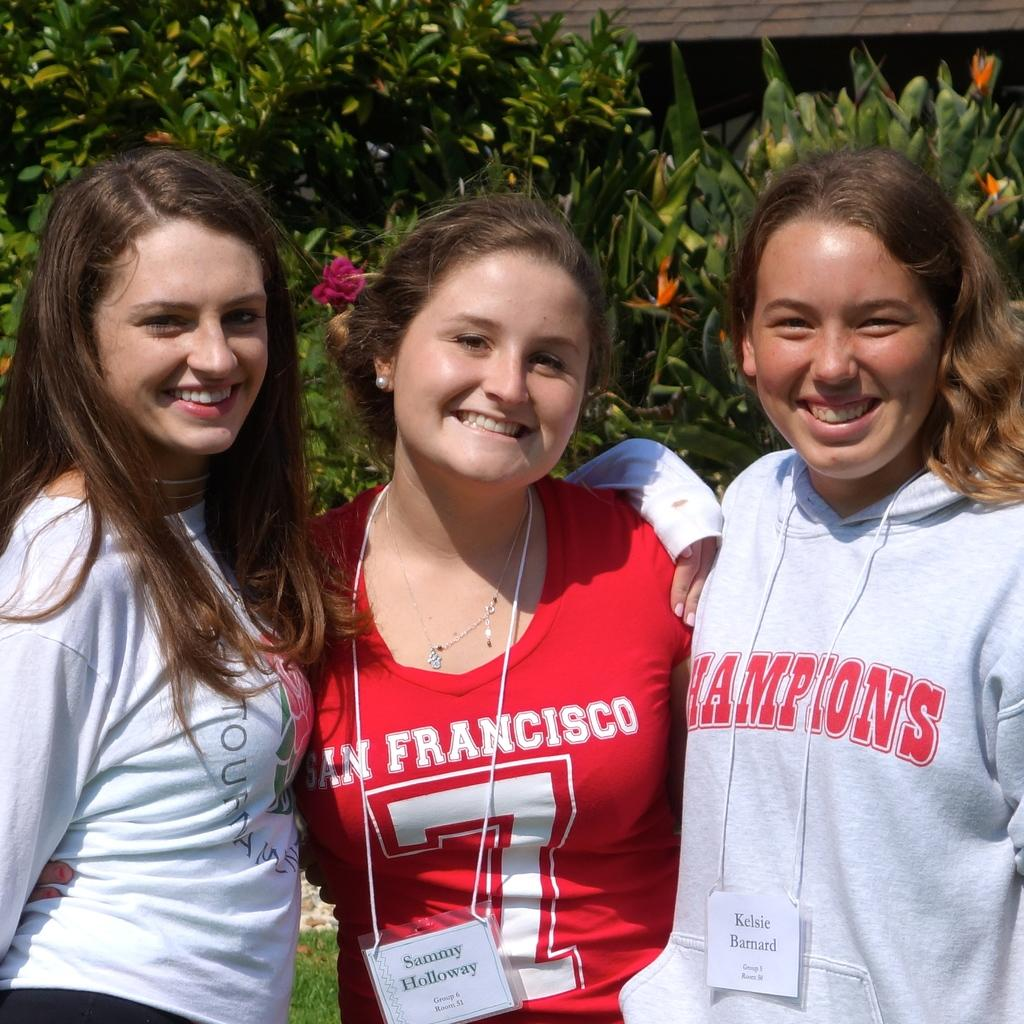What can be seen in the image? There is a group of women in the image. How are the women positioned in the image? The women are standing. What can be seen in the background of the image? There are plants with flowers visible in the background of the image. What type of sticks are being used by the women in the image? There is no mention of sticks in the image, so we cannot determine if any are being used by the women. 